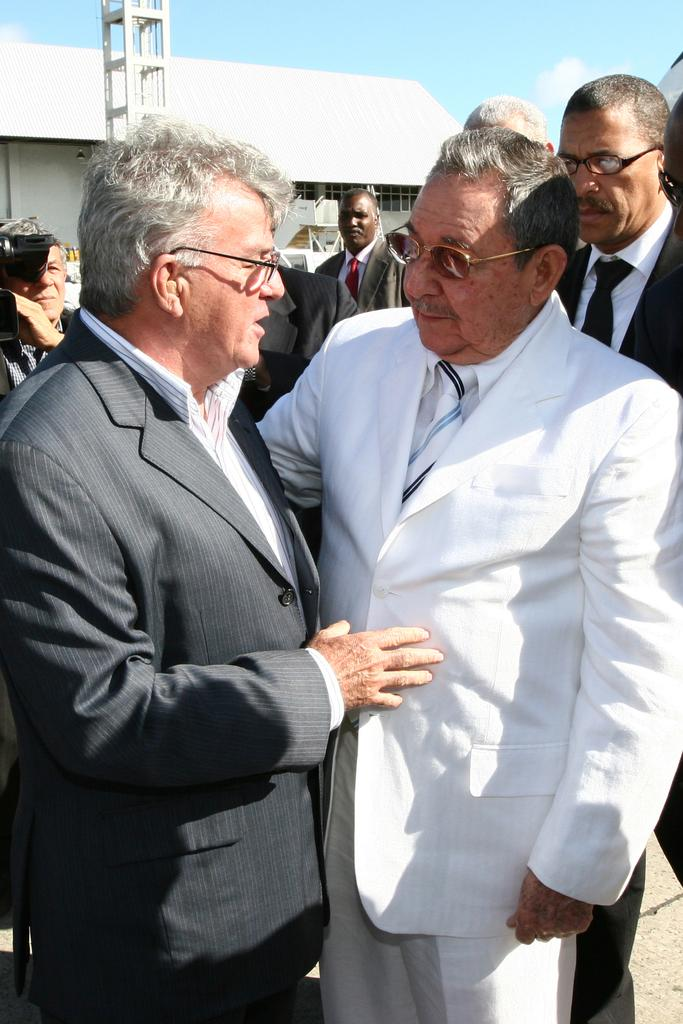What are the persons in the image wearing? The persons in the image are standing in suits. What are the persons doing in the image? The persons are talking. What can be seen in the background of the image? There is a building in the background of the image. What is visible in the sky in the image? The sky is visible in the image, and clouds are present. Can you see a giraffe in the image? No, there is no giraffe present in the image. What angle is the building in the image leaning at? The building in the image is not leaning; it is standing upright. 